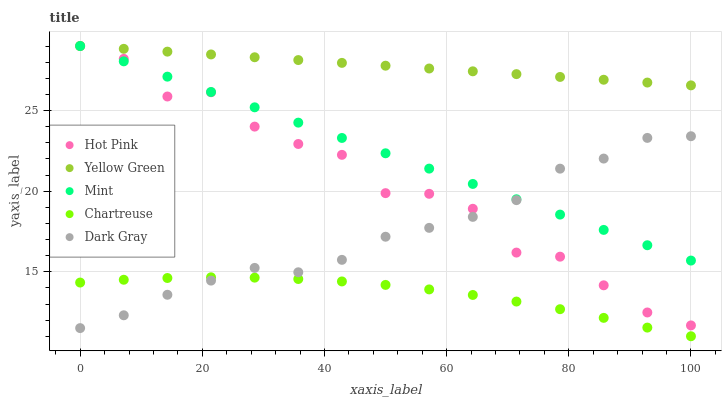Does Chartreuse have the minimum area under the curve?
Answer yes or no. Yes. Does Yellow Green have the maximum area under the curve?
Answer yes or no. Yes. Does Hot Pink have the minimum area under the curve?
Answer yes or no. No. Does Hot Pink have the maximum area under the curve?
Answer yes or no. No. Is Mint the smoothest?
Answer yes or no. Yes. Is Hot Pink the roughest?
Answer yes or no. Yes. Is Chartreuse the smoothest?
Answer yes or no. No. Is Chartreuse the roughest?
Answer yes or no. No. Does Chartreuse have the lowest value?
Answer yes or no. Yes. Does Hot Pink have the lowest value?
Answer yes or no. No. Does Yellow Green have the highest value?
Answer yes or no. Yes. Does Chartreuse have the highest value?
Answer yes or no. No. Is Chartreuse less than Hot Pink?
Answer yes or no. Yes. Is Mint greater than Chartreuse?
Answer yes or no. Yes. Does Yellow Green intersect Hot Pink?
Answer yes or no. Yes. Is Yellow Green less than Hot Pink?
Answer yes or no. No. Is Yellow Green greater than Hot Pink?
Answer yes or no. No. Does Chartreuse intersect Hot Pink?
Answer yes or no. No. 